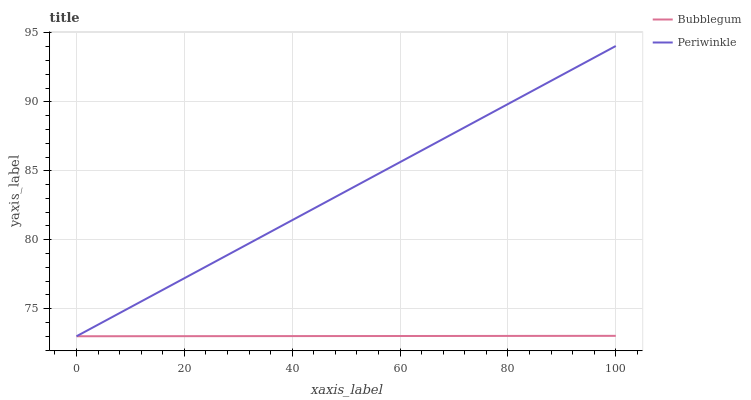Does Bubblegum have the minimum area under the curve?
Answer yes or no. Yes. Does Periwinkle have the maximum area under the curve?
Answer yes or no. Yes. Does Bubblegum have the maximum area under the curve?
Answer yes or no. No. Is Bubblegum the smoothest?
Answer yes or no. Yes. Is Periwinkle the roughest?
Answer yes or no. Yes. Is Bubblegum the roughest?
Answer yes or no. No. Does Periwinkle have the lowest value?
Answer yes or no. Yes. Does Periwinkle have the highest value?
Answer yes or no. Yes. Does Bubblegum have the highest value?
Answer yes or no. No. Does Periwinkle intersect Bubblegum?
Answer yes or no. Yes. Is Periwinkle less than Bubblegum?
Answer yes or no. No. Is Periwinkle greater than Bubblegum?
Answer yes or no. No. 